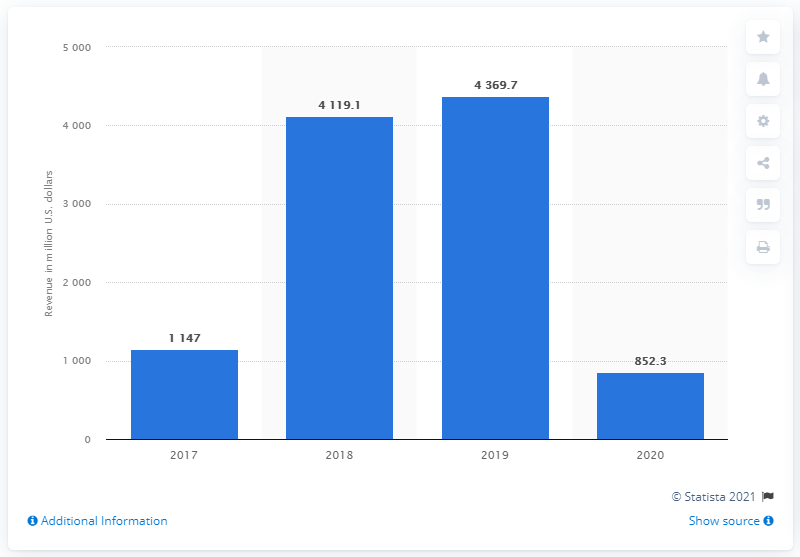Draw attention to some important aspects in this diagram. Cineworld Group's revenue in the year 2019 was approximately 4,369.7. In 2020, Cineworld Group reported global revenue of 852.3 million. 